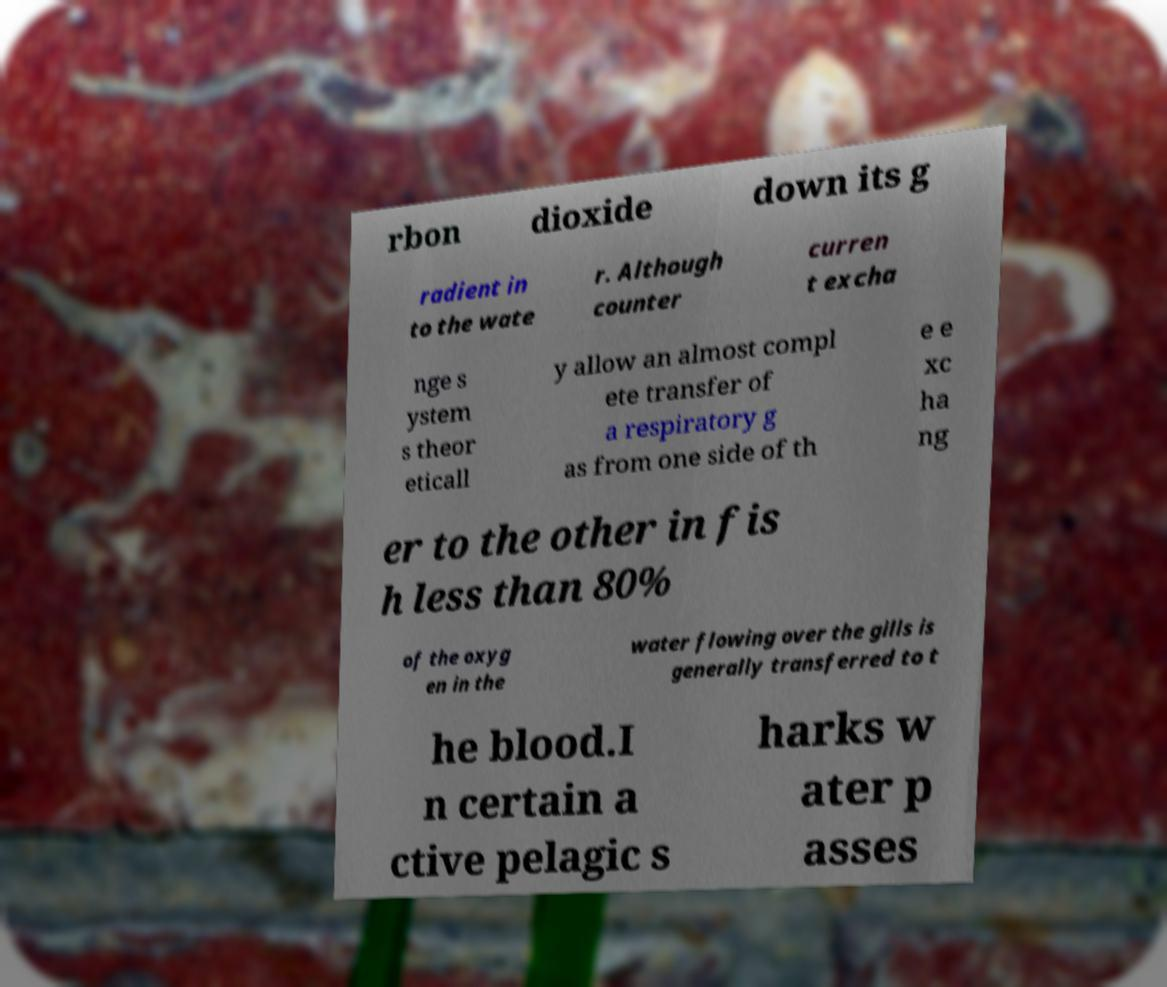Could you extract and type out the text from this image? rbon dioxide down its g radient in to the wate r. Although counter curren t excha nge s ystem s theor eticall y allow an almost compl ete transfer of a respiratory g as from one side of th e e xc ha ng er to the other in fis h less than 80% of the oxyg en in the water flowing over the gills is generally transferred to t he blood.I n certain a ctive pelagic s harks w ater p asses 